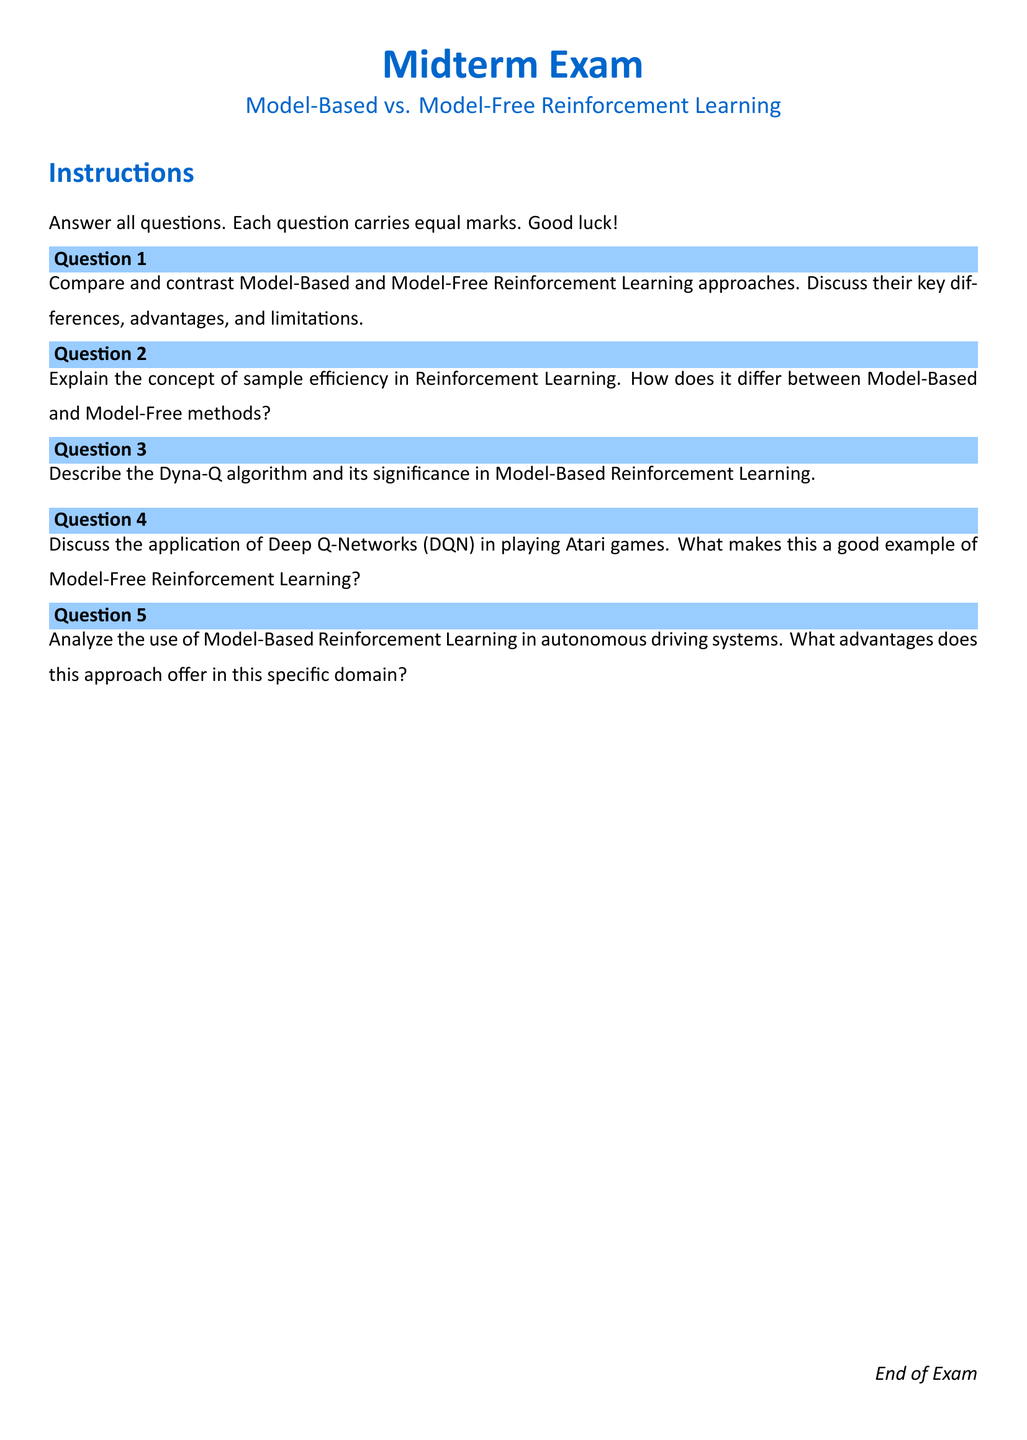What is the title of the exam? The title of the exam is indicated at the top of the document, stating the subject matter of the midterm exam.
Answer: Midterm Exam How many questions are there in the exam? The document lists five distinct questions, each numbered consecutively.
Answer: 5 What color is used for the section titles? The document uses a specific color defined as maincolor for the section titles, which provides visual emphasis.
Answer: maincolor What is the first question about? The first question prompts students to compare and contrast two primary approaches in Reinforcement Learning.
Answer: Model-Based and Model-Free Reinforcement Learning approaches What algorithm is discussed in Question 3? Question 3 specifically asks about a well-known algorithm in Model-Based Reinforcement Learning, which is significant in the field.
Answer: Dyna-Q What application is explored in Question 4? Question 4 focuses on a specific application of Model-Free Reinforcement Learning within the context of a popular video gaming platform.
Answer: Atari games What is one advantage of Model-Based Reinforcement Learning mentioned in the exam? The last question prompts analysis of advantages in a specific domain, leading to various possibilities.
Answer: Autonomous driving systems What is the date or year indicated in the document? The document does not explicitly mention any date or year, focusing instead on questions regarding Reinforcement Learning.
Answer: N/A 